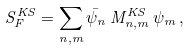<formula> <loc_0><loc_0><loc_500><loc_500>S _ { F } ^ { K S } = \sum _ { n , m } \bar { \psi } _ { n } \, M _ { n , m } ^ { K S } \, \psi _ { m } \, ,</formula> 